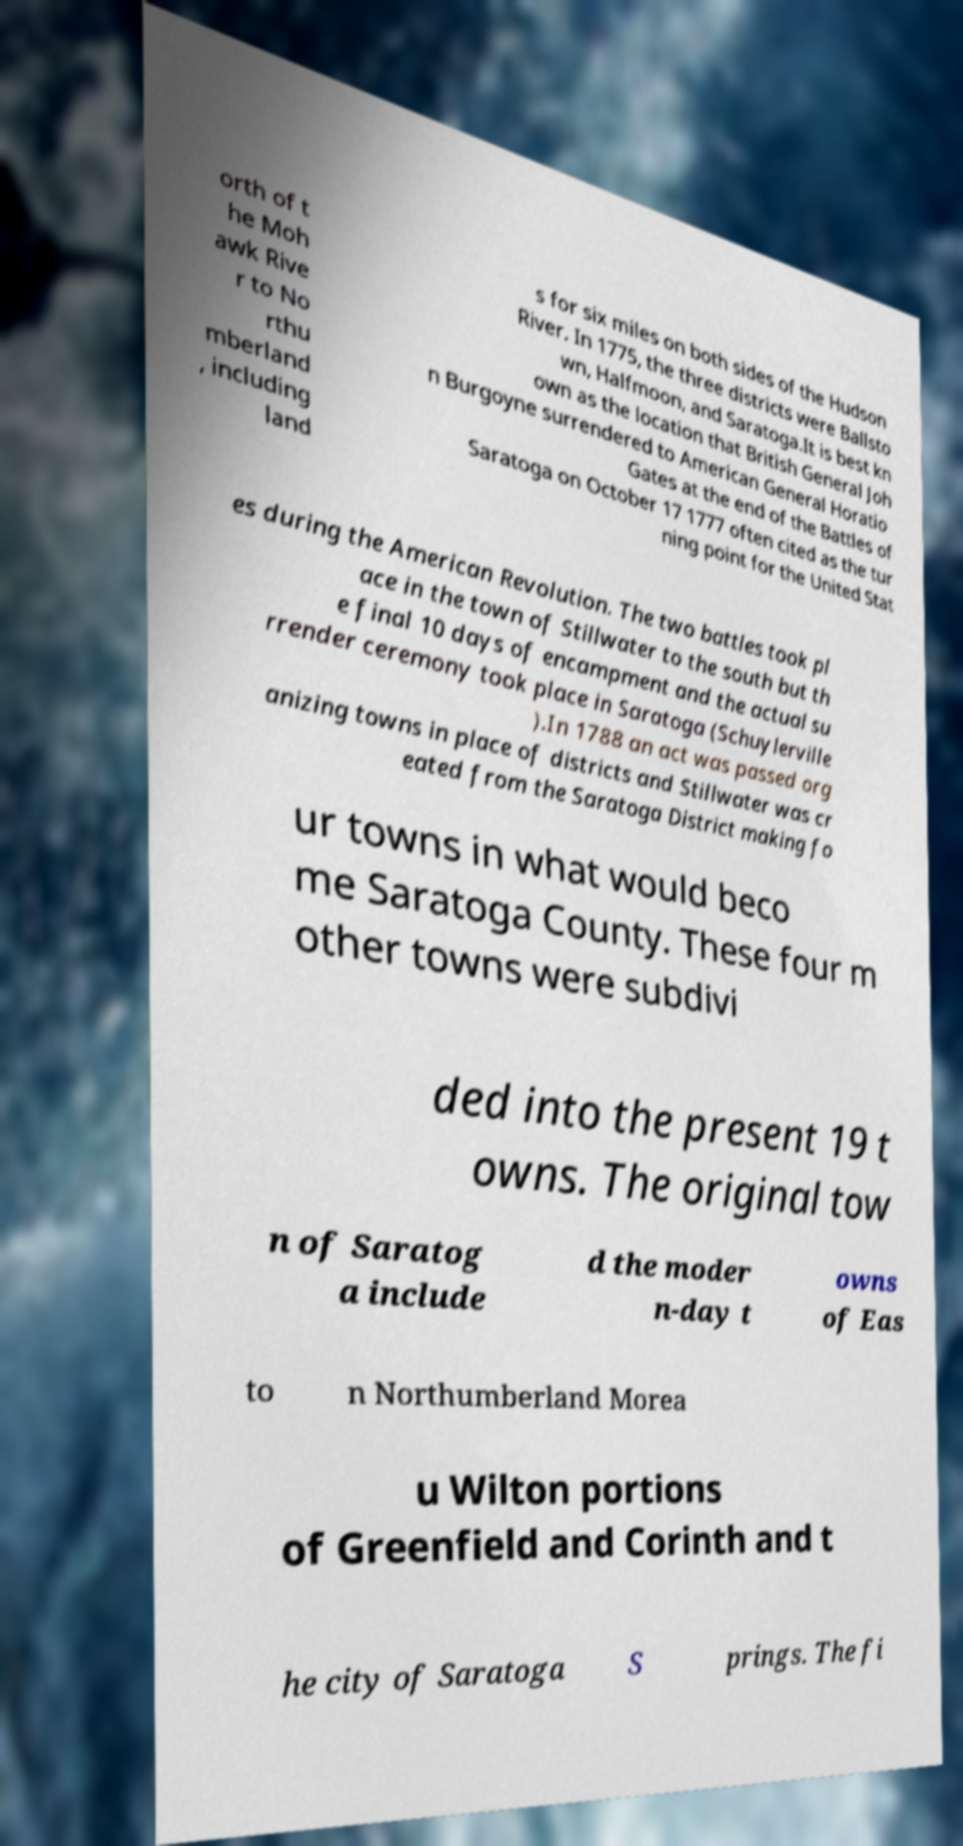Can you read and provide the text displayed in the image?This photo seems to have some interesting text. Can you extract and type it out for me? orth of t he Moh awk Rive r to No rthu mberland , including land s for six miles on both sides of the Hudson River. In 1775, the three districts were Ballsto wn, Halfmoon, and Saratoga.It is best kn own as the location that British General Joh n Burgoyne surrendered to American General Horatio Gates at the end of the Battles of Saratoga on October 17 1777 often cited as the tur ning point for the United Stat es during the American Revolution. The two battles took pl ace in the town of Stillwater to the south but th e final 10 days of encampment and the actual su rrender ceremony took place in Saratoga (Schuylerville ).In 1788 an act was passed org anizing towns in place of districts and Stillwater was cr eated from the Saratoga District making fo ur towns in what would beco me Saratoga County. These four m other towns were subdivi ded into the present 19 t owns. The original tow n of Saratog a include d the moder n-day t owns of Eas to n Northumberland Morea u Wilton portions of Greenfield and Corinth and t he city of Saratoga S prings. The fi 